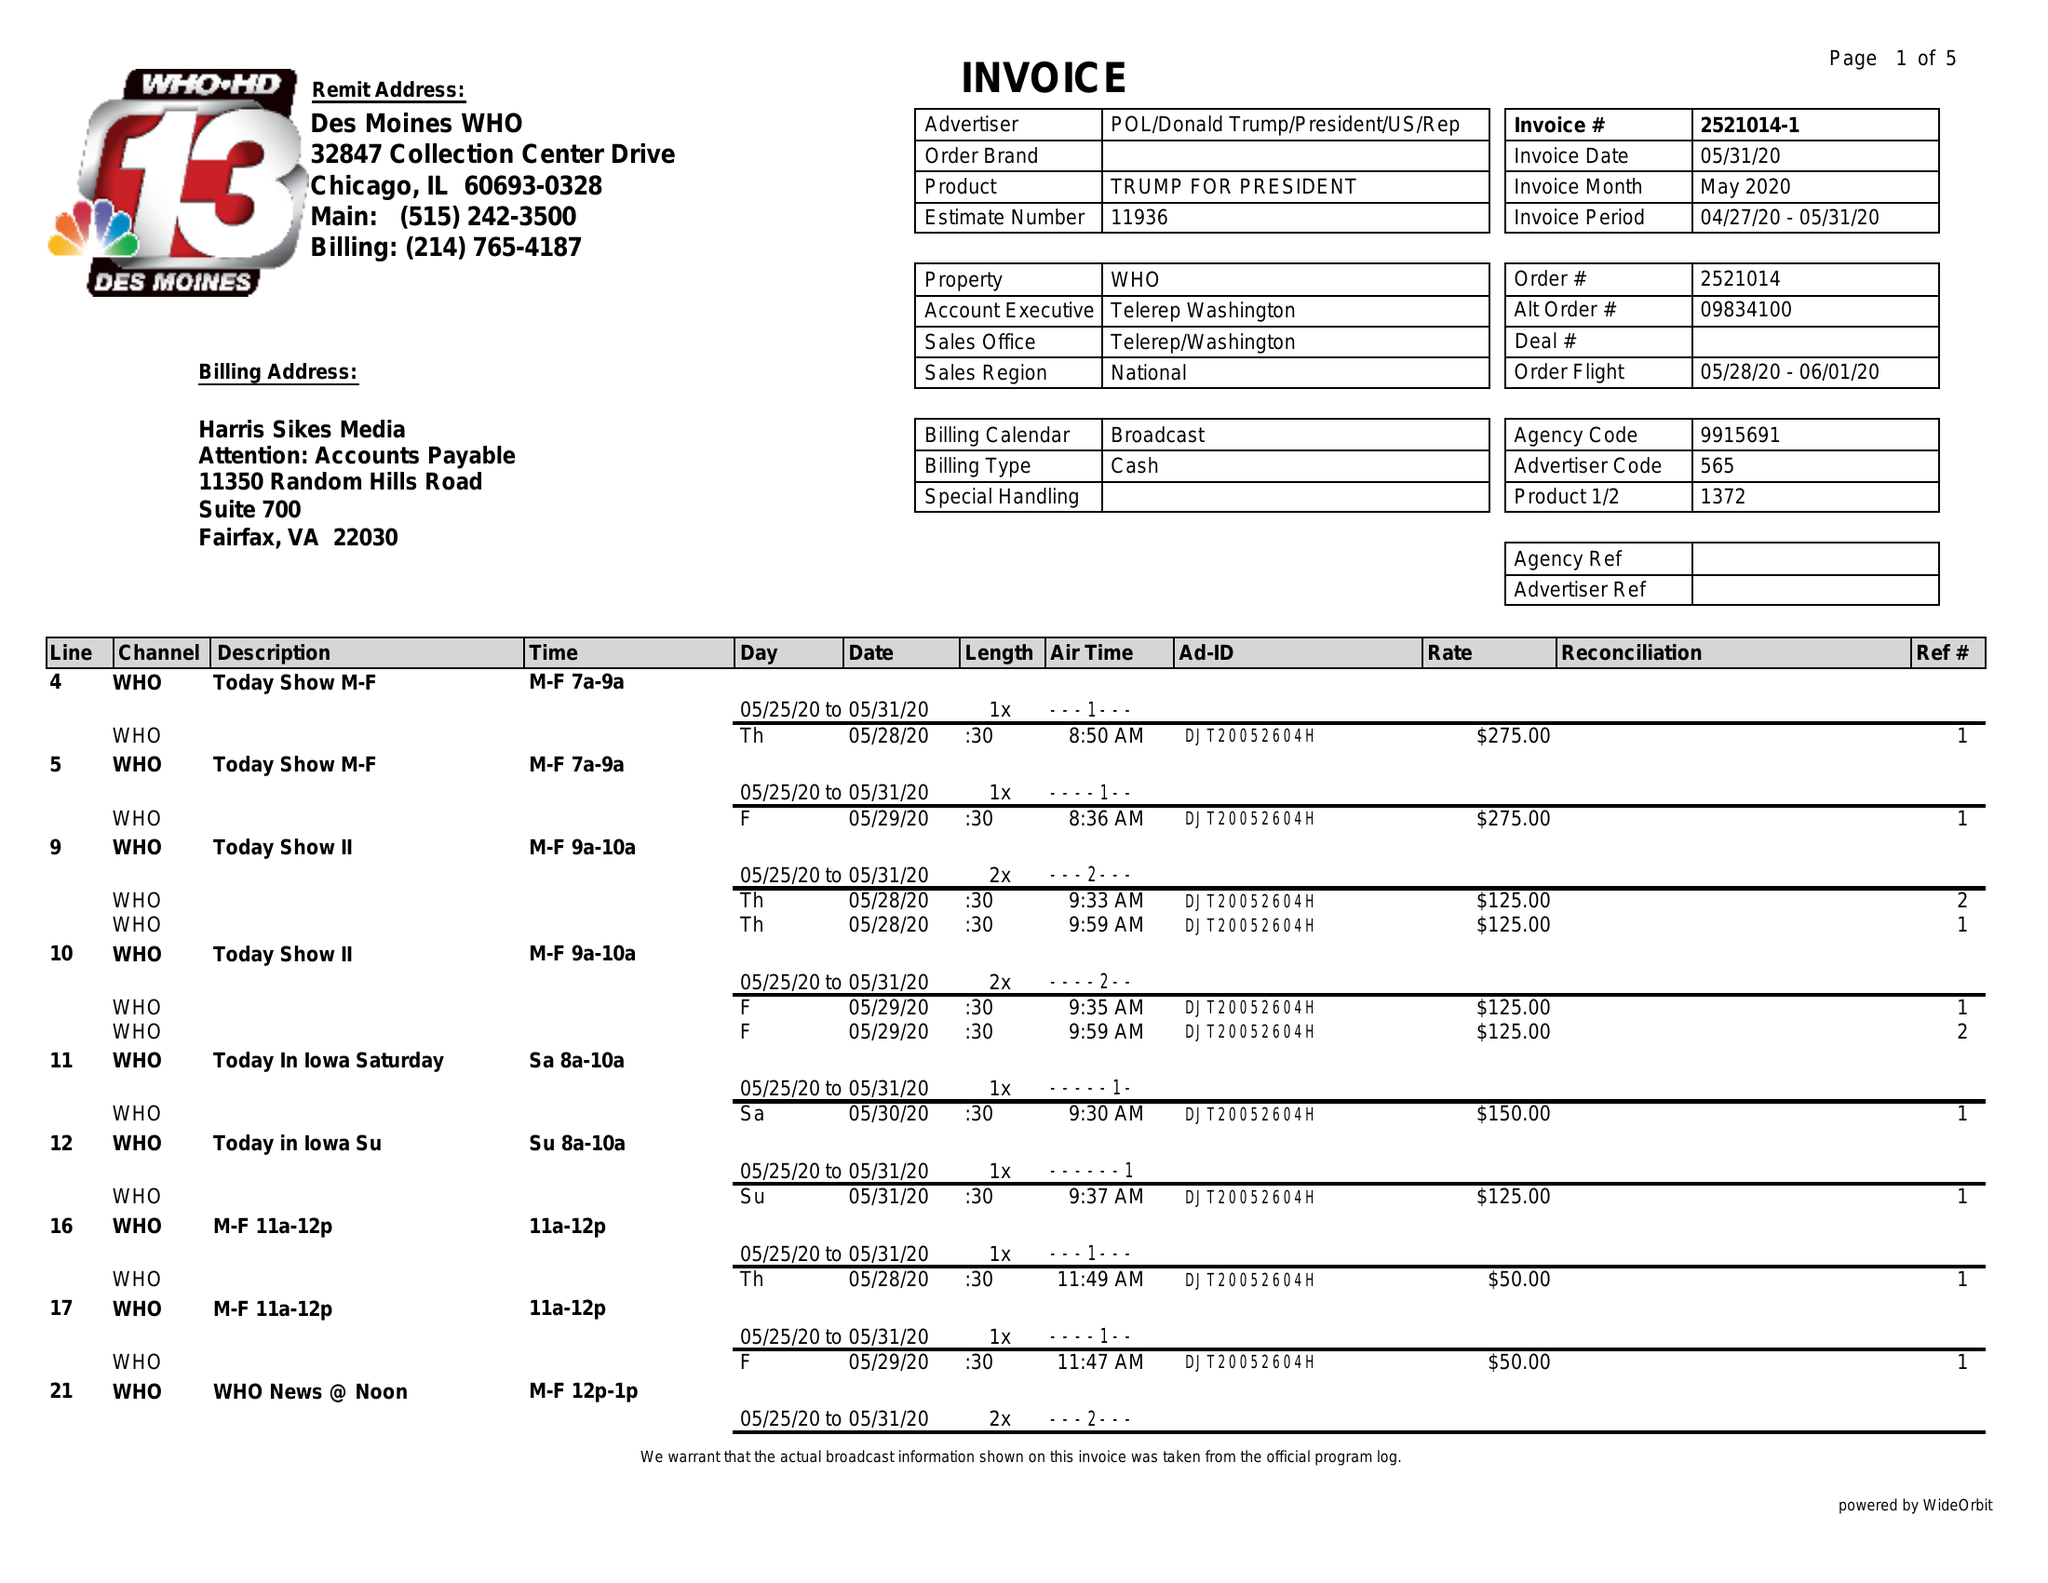What is the value for the gross_amount?
Answer the question using a single word or phrase. 8260.00 